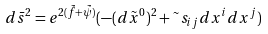<formula> <loc_0><loc_0><loc_500><loc_500>d \bar { s } ^ { 2 } = e ^ { 2 ( \tilde { f } + \tilde { \psi } ) } ( - ( d \tilde { x } ^ { 0 } ) ^ { 2 } + \tilde { \ } s _ { i j } d x ^ { i } d x ^ { j } )</formula> 